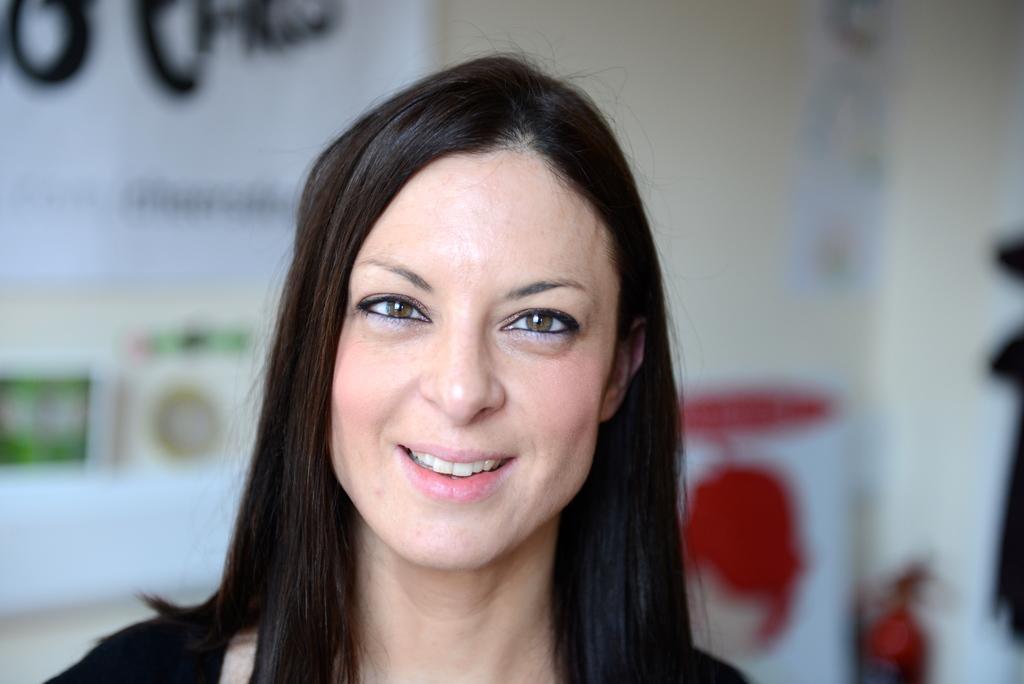In one or two sentences, can you explain what this image depicts? This is the woman smiling. I think here is the banner, which is attached to the wall. This looks like an object. 